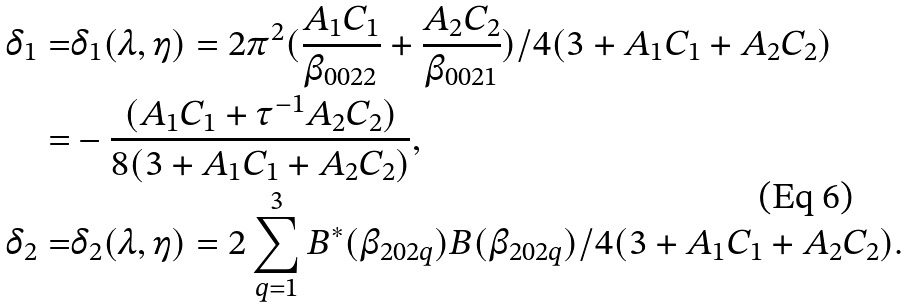<formula> <loc_0><loc_0><loc_500><loc_500>\delta _ { 1 } = & \delta _ { 1 } ( \lambda , \eta ) = 2 \pi ^ { 2 } ( \frac { A _ { 1 } C _ { 1 } } { \beta _ { 0 0 2 2 } } + \frac { A _ { 2 } C _ { 2 } } { \beta _ { 0 0 2 1 } } ) / 4 ( 3 + A _ { 1 } C _ { 1 } + A _ { 2 } C _ { 2 } ) \\ = & - \frac { ( A _ { 1 } C _ { 1 } + \tau ^ { - 1 } A _ { 2 } C _ { 2 } ) } { 8 ( 3 + A _ { 1 } C _ { 1 } + A _ { 2 } C _ { 2 } ) } , \\ \delta _ { 2 } = & \delta _ { 2 } ( \lambda , \eta ) = 2 \sum _ { q = 1 } ^ { 3 } B ^ { * } ( \beta _ { 2 0 2 q } ) B ( \beta _ { 2 0 2 q } ) / 4 ( 3 + A _ { 1 } C _ { 1 } + A _ { 2 } C _ { 2 } ) .</formula> 